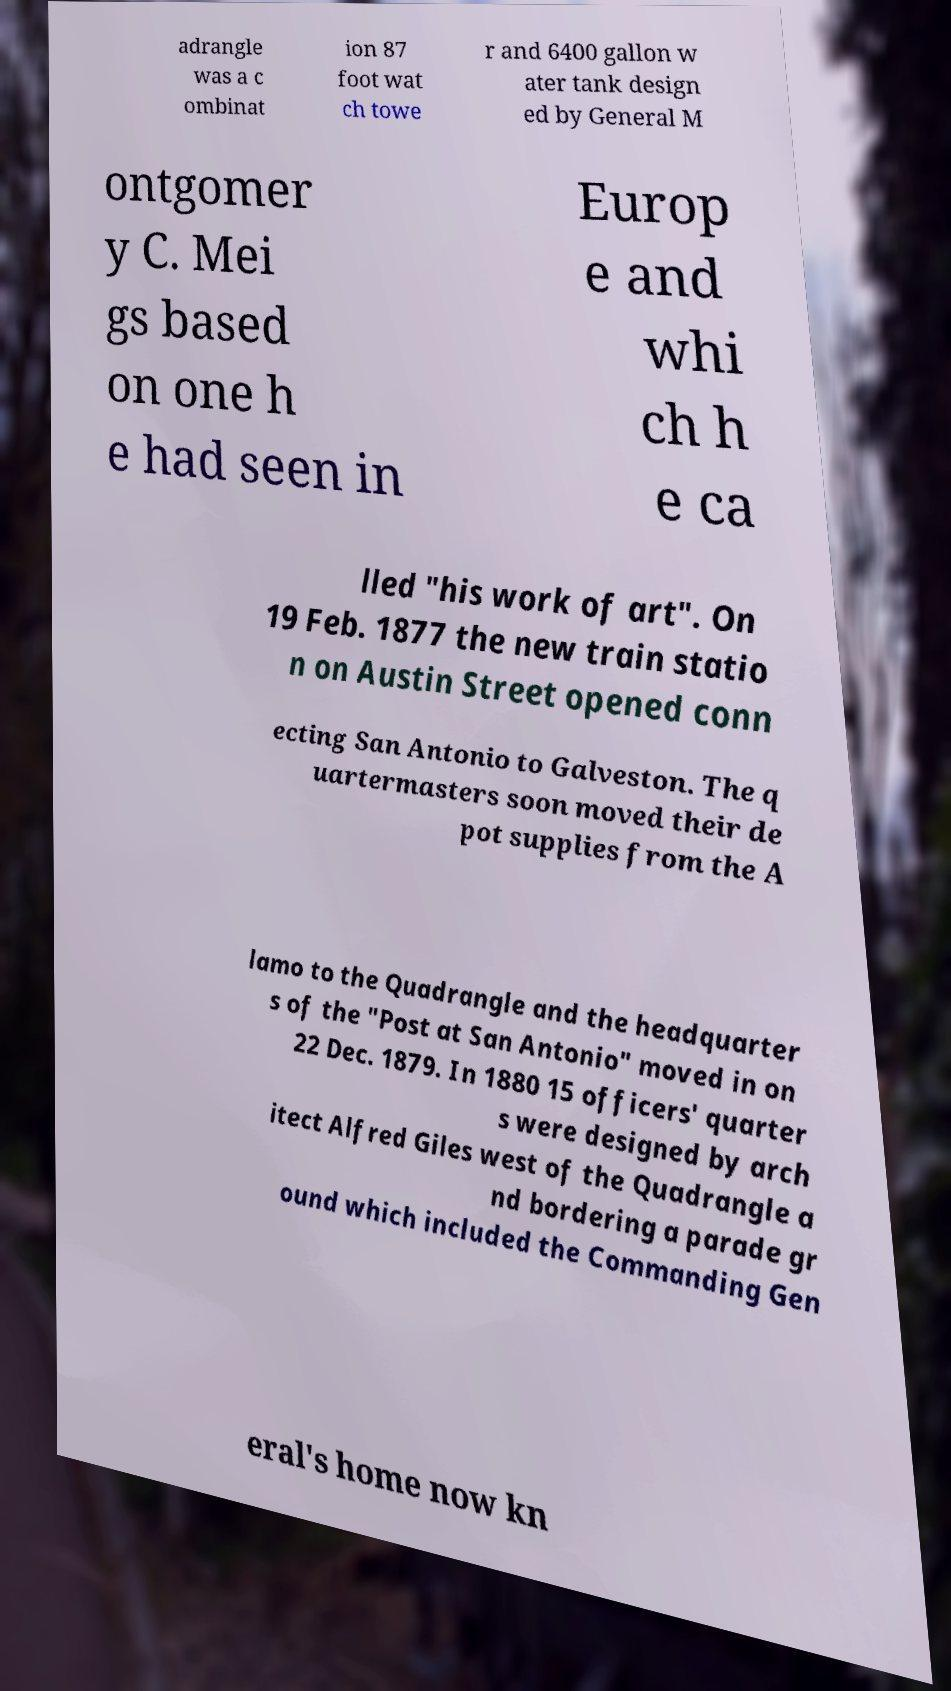Please read and relay the text visible in this image. What does it say? adrangle was a c ombinat ion 87 foot wat ch towe r and 6400 gallon w ater tank design ed by General M ontgomer y C. Mei gs based on one h e had seen in Europ e and whi ch h e ca lled "his work of art". On 19 Feb. 1877 the new train statio n on Austin Street opened conn ecting San Antonio to Galveston. The q uartermasters soon moved their de pot supplies from the A lamo to the Quadrangle and the headquarter s of the "Post at San Antonio" moved in on 22 Dec. 1879. In 1880 15 officers' quarter s were designed by arch itect Alfred Giles west of the Quadrangle a nd bordering a parade gr ound which included the Commanding Gen eral's home now kn 